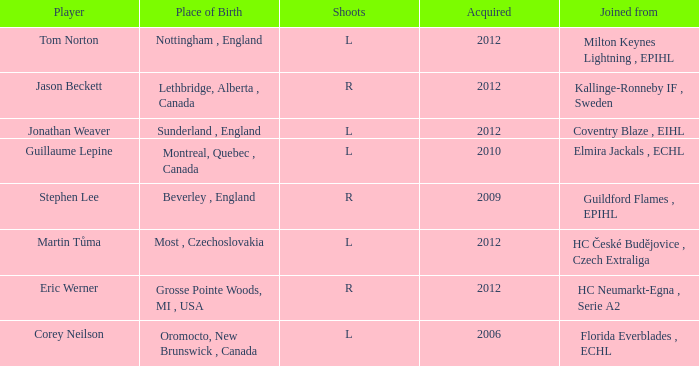Who acquired tom norton? 2012.0. 